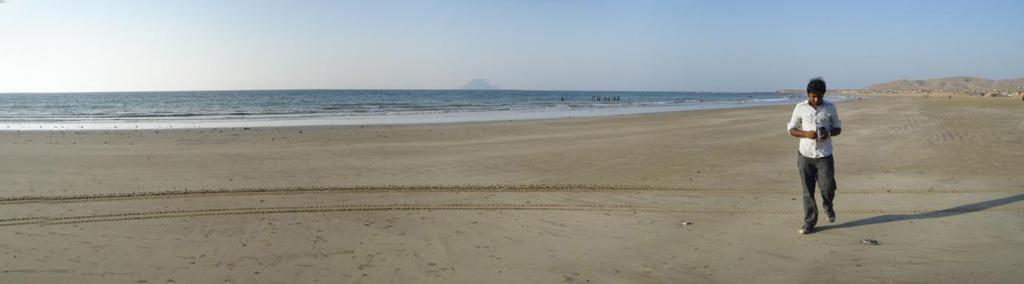Could you give a brief overview of what you see in this image? In the image there is a man walking on the seashore. Behind him there is sea. In the background there are hills. At the top of the image there is sky. 